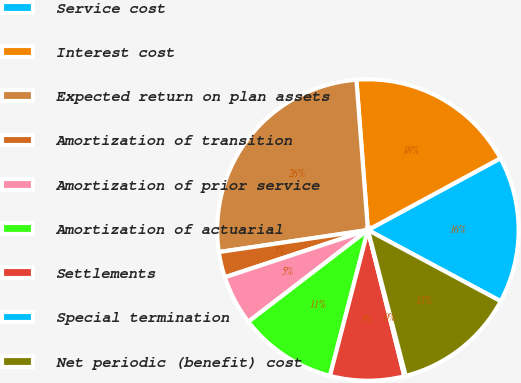<chart> <loc_0><loc_0><loc_500><loc_500><pie_chart><fcel>Service cost<fcel>Interest cost<fcel>Expected return on plan assets<fcel>Amortization of transition<fcel>Amortization of prior service<fcel>Amortization of actuarial<fcel>Settlements<fcel>Special termination<fcel>Net periodic (benefit) cost<nl><fcel>15.73%<fcel>18.32%<fcel>26.12%<fcel>2.74%<fcel>5.34%<fcel>10.53%<fcel>7.94%<fcel>0.15%<fcel>13.13%<nl></chart> 